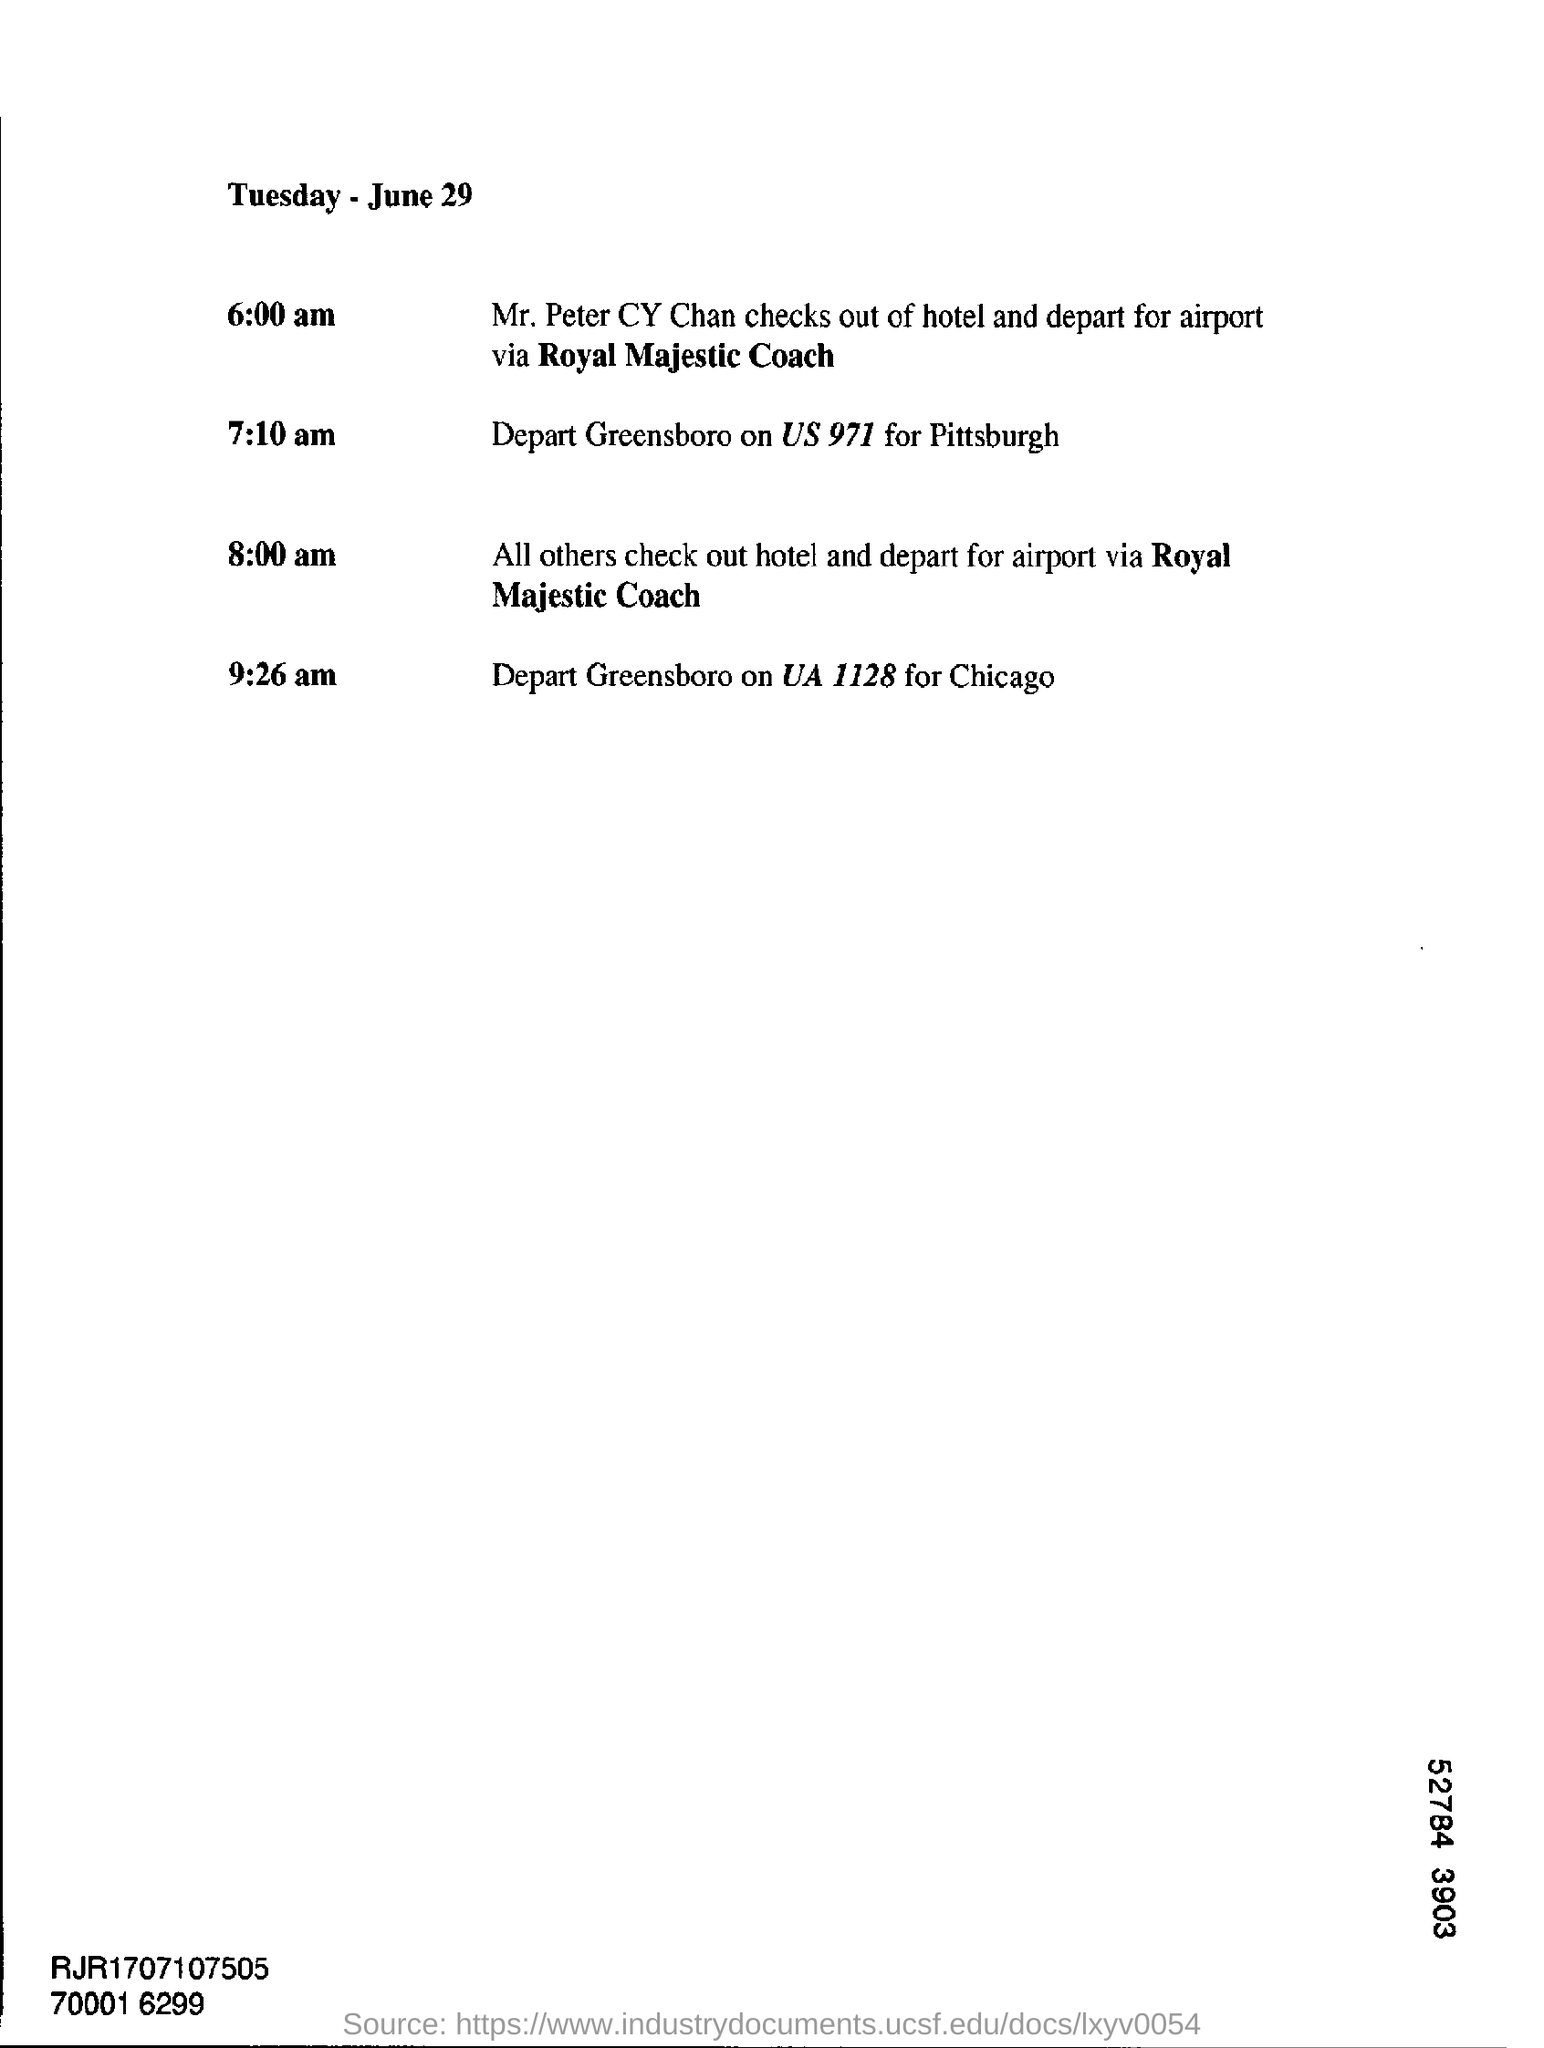Identify some key points in this picture. Mr. Peter CY Chan plans to check out of the hotel at 6:00 am. At 7:10 a.m. on the specified date, US 971 will depart for Pittsburg. At 9:26 a.m., Greensboro will depart. Mr. Peter had gone to the airport from the hotel. June 29, as per the document, falls on a Tuesday. 